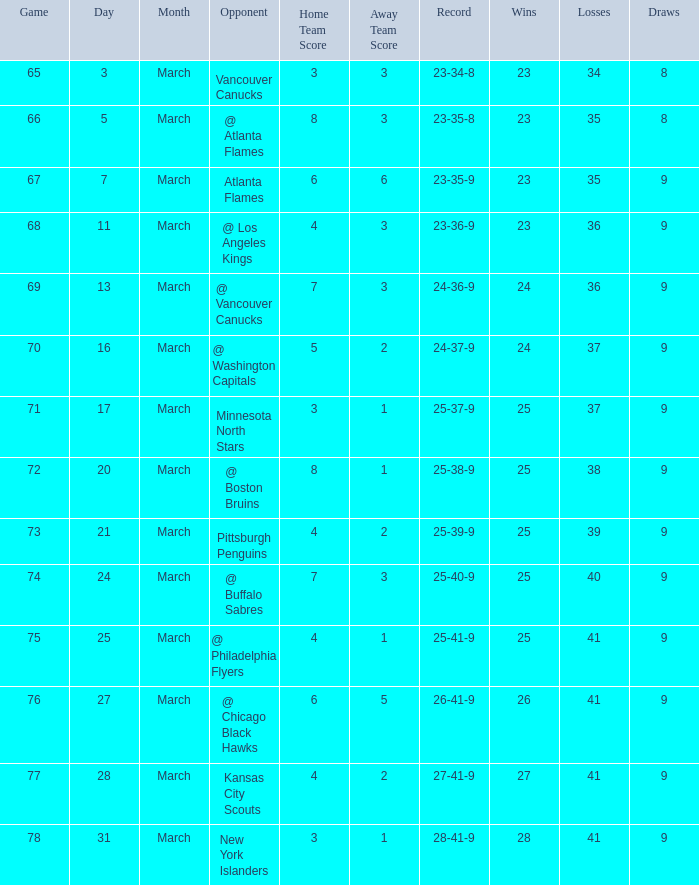What was the score when they had a 25-41-9 record? 4 - 1. 